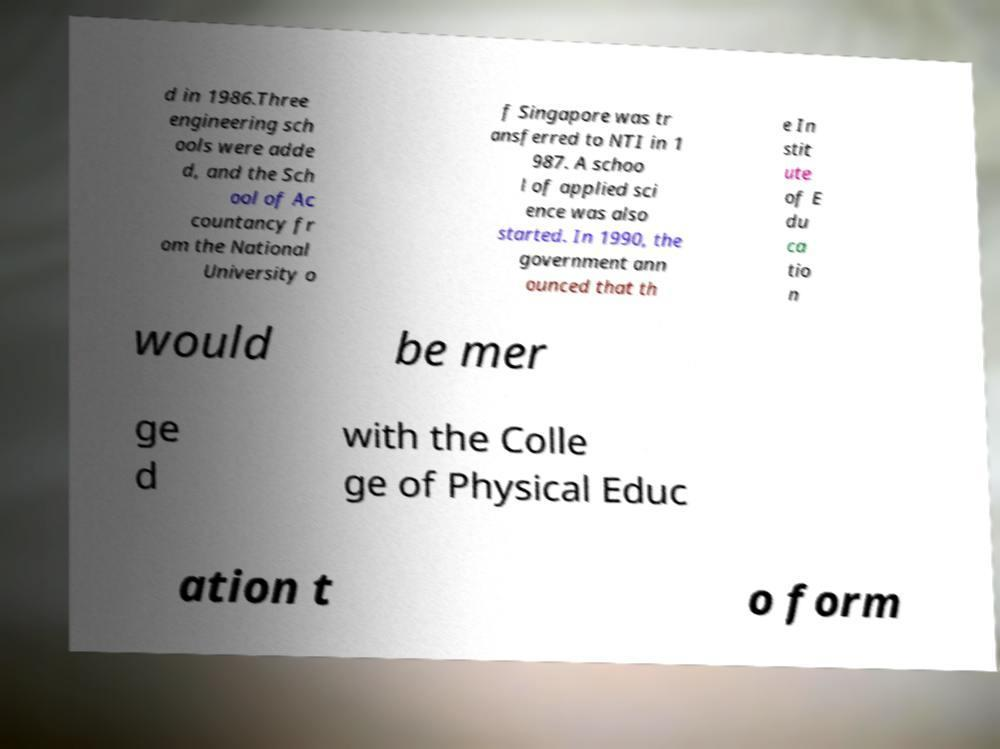Please identify and transcribe the text found in this image. d in 1986.Three engineering sch ools were adde d, and the Sch ool of Ac countancy fr om the National University o f Singapore was tr ansferred to NTI in 1 987. A schoo l of applied sci ence was also started. In 1990, the government ann ounced that th e In stit ute of E du ca tio n would be mer ge d with the Colle ge of Physical Educ ation t o form 